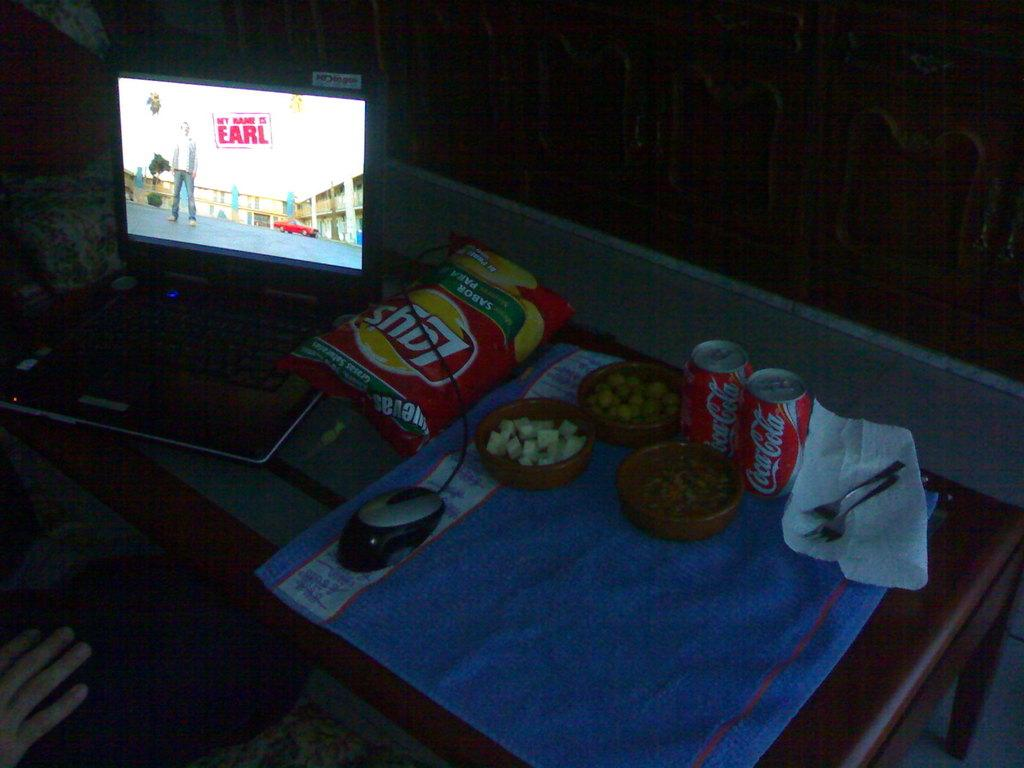<image>
Share a concise interpretation of the image provided. A screen that says Hey My Name is Earl on it with Lays chips and Coke next to it. 